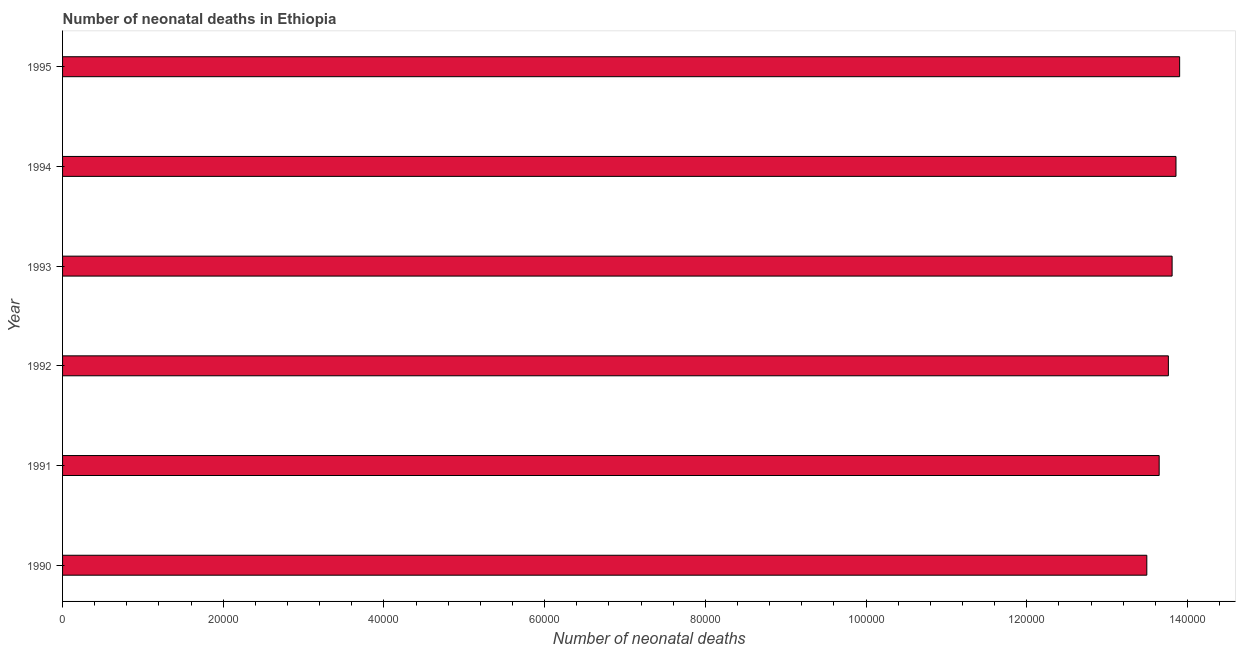What is the title of the graph?
Your answer should be compact. Number of neonatal deaths in Ethiopia. What is the label or title of the X-axis?
Provide a short and direct response. Number of neonatal deaths. What is the label or title of the Y-axis?
Give a very brief answer. Year. What is the number of neonatal deaths in 1990?
Offer a very short reply. 1.35e+05. Across all years, what is the maximum number of neonatal deaths?
Your answer should be very brief. 1.39e+05. Across all years, what is the minimum number of neonatal deaths?
Offer a very short reply. 1.35e+05. In which year was the number of neonatal deaths maximum?
Offer a very short reply. 1995. What is the sum of the number of neonatal deaths?
Your answer should be very brief. 8.25e+05. What is the difference between the number of neonatal deaths in 1992 and 1995?
Your answer should be compact. -1402. What is the average number of neonatal deaths per year?
Your answer should be compact. 1.37e+05. What is the median number of neonatal deaths?
Make the answer very short. 1.38e+05. Do a majority of the years between 1990 and 1992 (inclusive) have number of neonatal deaths greater than 96000 ?
Provide a short and direct response. Yes. What is the ratio of the number of neonatal deaths in 1992 to that in 1994?
Provide a succinct answer. 0.99. Is the difference between the number of neonatal deaths in 1993 and 1994 greater than the difference between any two years?
Ensure brevity in your answer.  No. What is the difference between the highest and the second highest number of neonatal deaths?
Keep it short and to the point. 454. What is the difference between the highest and the lowest number of neonatal deaths?
Offer a terse response. 4085. In how many years, is the number of neonatal deaths greater than the average number of neonatal deaths taken over all years?
Ensure brevity in your answer.  4. How many bars are there?
Your response must be concise. 6. Are the values on the major ticks of X-axis written in scientific E-notation?
Offer a terse response. No. What is the Number of neonatal deaths of 1990?
Offer a very short reply. 1.35e+05. What is the Number of neonatal deaths of 1991?
Ensure brevity in your answer.  1.36e+05. What is the Number of neonatal deaths of 1992?
Your answer should be compact. 1.38e+05. What is the Number of neonatal deaths in 1993?
Your response must be concise. 1.38e+05. What is the Number of neonatal deaths in 1994?
Ensure brevity in your answer.  1.39e+05. What is the Number of neonatal deaths of 1995?
Provide a succinct answer. 1.39e+05. What is the difference between the Number of neonatal deaths in 1990 and 1991?
Provide a succinct answer. -1538. What is the difference between the Number of neonatal deaths in 1990 and 1992?
Offer a very short reply. -2683. What is the difference between the Number of neonatal deaths in 1990 and 1993?
Your response must be concise. -3147. What is the difference between the Number of neonatal deaths in 1990 and 1994?
Offer a very short reply. -3631. What is the difference between the Number of neonatal deaths in 1990 and 1995?
Provide a succinct answer. -4085. What is the difference between the Number of neonatal deaths in 1991 and 1992?
Give a very brief answer. -1145. What is the difference between the Number of neonatal deaths in 1991 and 1993?
Provide a short and direct response. -1609. What is the difference between the Number of neonatal deaths in 1991 and 1994?
Ensure brevity in your answer.  -2093. What is the difference between the Number of neonatal deaths in 1991 and 1995?
Give a very brief answer. -2547. What is the difference between the Number of neonatal deaths in 1992 and 1993?
Give a very brief answer. -464. What is the difference between the Number of neonatal deaths in 1992 and 1994?
Give a very brief answer. -948. What is the difference between the Number of neonatal deaths in 1992 and 1995?
Provide a short and direct response. -1402. What is the difference between the Number of neonatal deaths in 1993 and 1994?
Offer a terse response. -484. What is the difference between the Number of neonatal deaths in 1993 and 1995?
Give a very brief answer. -938. What is the difference between the Number of neonatal deaths in 1994 and 1995?
Provide a short and direct response. -454. What is the ratio of the Number of neonatal deaths in 1990 to that in 1991?
Your answer should be very brief. 0.99. What is the ratio of the Number of neonatal deaths in 1990 to that in 1992?
Give a very brief answer. 0.98. What is the ratio of the Number of neonatal deaths in 1990 to that in 1993?
Your response must be concise. 0.98. What is the ratio of the Number of neonatal deaths in 1990 to that in 1995?
Your answer should be very brief. 0.97. What is the ratio of the Number of neonatal deaths in 1991 to that in 1992?
Make the answer very short. 0.99. What is the ratio of the Number of neonatal deaths in 1991 to that in 1994?
Keep it short and to the point. 0.98. What is the ratio of the Number of neonatal deaths in 1991 to that in 1995?
Make the answer very short. 0.98. What is the ratio of the Number of neonatal deaths in 1993 to that in 1994?
Your response must be concise. 1. What is the ratio of the Number of neonatal deaths in 1993 to that in 1995?
Your response must be concise. 0.99. What is the ratio of the Number of neonatal deaths in 1994 to that in 1995?
Make the answer very short. 1. 